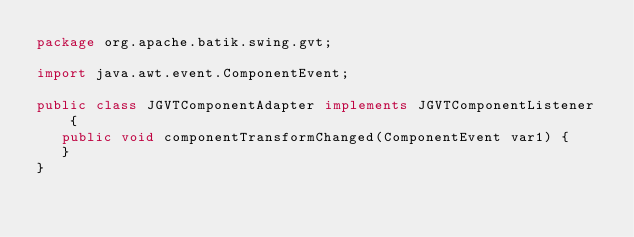Convert code to text. <code><loc_0><loc_0><loc_500><loc_500><_Java_>package org.apache.batik.swing.gvt;

import java.awt.event.ComponentEvent;

public class JGVTComponentAdapter implements JGVTComponentListener {
   public void componentTransformChanged(ComponentEvent var1) {
   }
}
</code> 